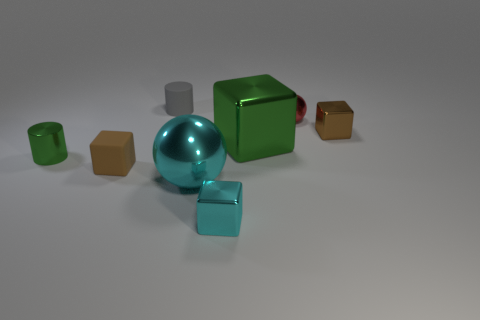Do the green cylinder and the cyan shiny sphere have the same size?
Provide a short and direct response. No. How many big objects are red balls or gray cylinders?
Offer a very short reply. 0. How many green metal cubes are to the left of the small red metal ball?
Keep it short and to the point. 1. Is the number of rubber blocks in front of the brown metallic thing greater than the number of tiny cyan metallic spheres?
Provide a succinct answer. Yes. There is a large cyan object that is the same material as the small cyan block; what is its shape?
Your answer should be very brief. Sphere. What color is the tiny matte object behind the small matte thing that is to the left of the tiny gray cylinder?
Provide a short and direct response. Gray. Is the shape of the large green object the same as the tiny brown matte object?
Provide a short and direct response. Yes. What material is the other thing that is the same shape as the small red thing?
Make the answer very short. Metal. There is a tiny metal object in front of the metallic sphere that is on the left side of the large green cube; is there a large metallic object that is right of it?
Provide a succinct answer. Yes. Do the big cyan object and the red shiny object that is right of the tiny green thing have the same shape?
Provide a succinct answer. Yes. 